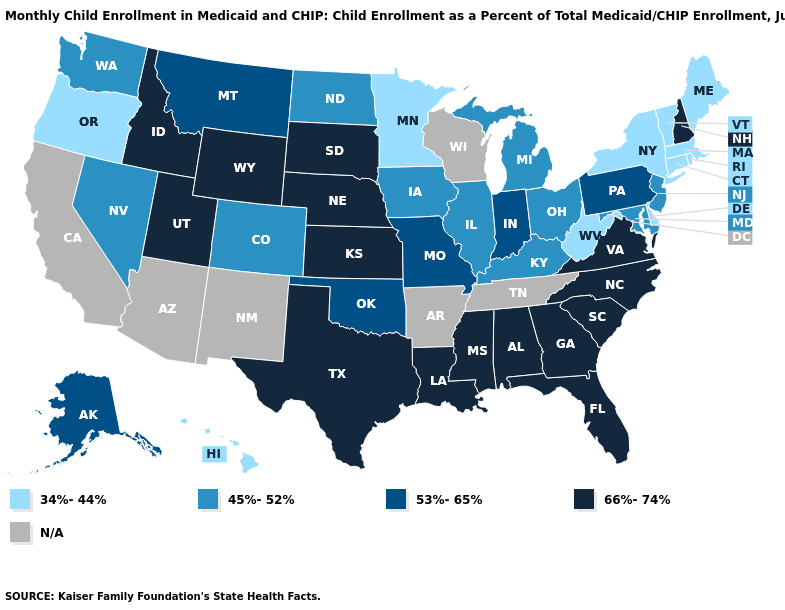Name the states that have a value in the range 66%-74%?
Keep it brief. Alabama, Florida, Georgia, Idaho, Kansas, Louisiana, Mississippi, Nebraska, New Hampshire, North Carolina, South Carolina, South Dakota, Texas, Utah, Virginia, Wyoming. Name the states that have a value in the range 45%-52%?
Keep it brief. Colorado, Illinois, Iowa, Kentucky, Maryland, Michigan, Nevada, New Jersey, North Dakota, Ohio, Washington. Among the states that border Utah , which have the lowest value?
Answer briefly. Colorado, Nevada. Name the states that have a value in the range N/A?
Be succinct. Arizona, Arkansas, California, New Mexico, Tennessee, Wisconsin. Does New Hampshire have the lowest value in the USA?
Quick response, please. No. What is the value of Delaware?
Give a very brief answer. 34%-44%. Does the map have missing data?
Quick response, please. Yes. Name the states that have a value in the range 53%-65%?
Answer briefly. Alaska, Indiana, Missouri, Montana, Oklahoma, Pennsylvania. What is the value of Massachusetts?
Give a very brief answer. 34%-44%. Is the legend a continuous bar?
Quick response, please. No. What is the value of Mississippi?
Write a very short answer. 66%-74%. Name the states that have a value in the range 66%-74%?
Write a very short answer. Alabama, Florida, Georgia, Idaho, Kansas, Louisiana, Mississippi, Nebraska, New Hampshire, North Carolina, South Carolina, South Dakota, Texas, Utah, Virginia, Wyoming. What is the value of Mississippi?
Concise answer only. 66%-74%. What is the value of Wyoming?
Keep it brief. 66%-74%. Name the states that have a value in the range 53%-65%?
Keep it brief. Alaska, Indiana, Missouri, Montana, Oklahoma, Pennsylvania. 